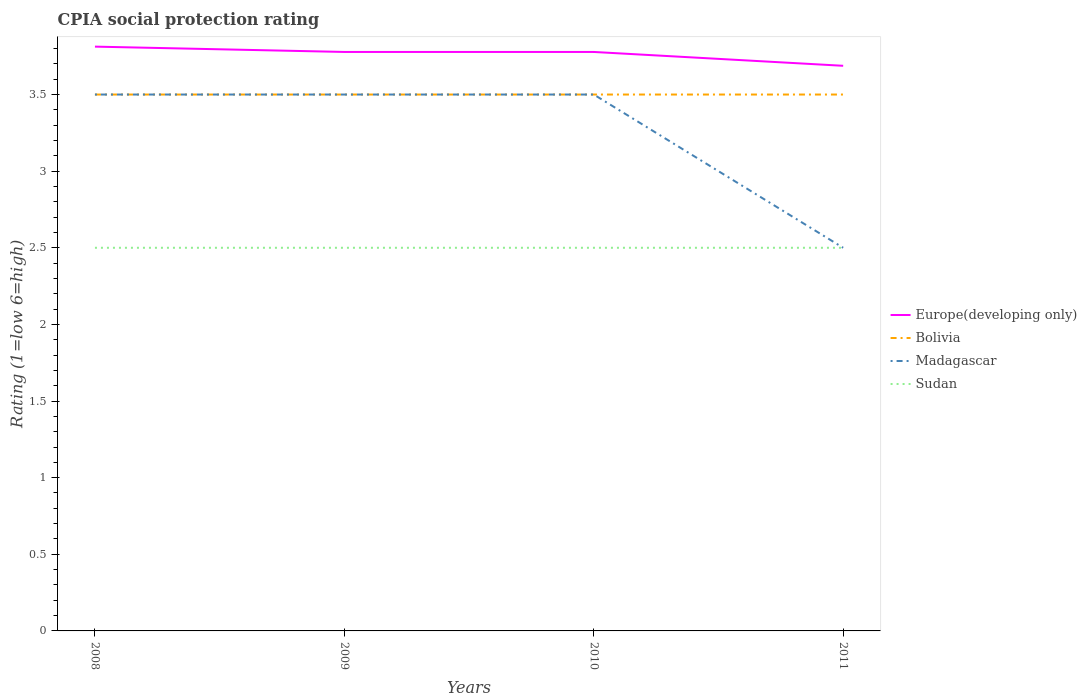In which year was the CPIA rating in Sudan maximum?
Make the answer very short. 2008. What is the difference between the highest and the second highest CPIA rating in Europe(developing only)?
Your response must be concise. 0.12. How many lines are there?
Keep it short and to the point. 4. What is the difference between two consecutive major ticks on the Y-axis?
Offer a terse response. 0.5. Are the values on the major ticks of Y-axis written in scientific E-notation?
Ensure brevity in your answer.  No. Does the graph contain any zero values?
Offer a terse response. No. How many legend labels are there?
Offer a very short reply. 4. What is the title of the graph?
Offer a very short reply. CPIA social protection rating. Does "Middle income" appear as one of the legend labels in the graph?
Make the answer very short. No. What is the label or title of the X-axis?
Ensure brevity in your answer.  Years. What is the label or title of the Y-axis?
Keep it short and to the point. Rating (1=low 6=high). What is the Rating (1=low 6=high) in Europe(developing only) in 2008?
Provide a succinct answer. 3.81. What is the Rating (1=low 6=high) of Madagascar in 2008?
Make the answer very short. 3.5. What is the Rating (1=low 6=high) of Europe(developing only) in 2009?
Your answer should be compact. 3.78. What is the Rating (1=low 6=high) of Bolivia in 2009?
Offer a very short reply. 3.5. What is the Rating (1=low 6=high) of Madagascar in 2009?
Your answer should be very brief. 3.5. What is the Rating (1=low 6=high) in Sudan in 2009?
Provide a succinct answer. 2.5. What is the Rating (1=low 6=high) in Europe(developing only) in 2010?
Make the answer very short. 3.78. What is the Rating (1=low 6=high) in Bolivia in 2010?
Your response must be concise. 3.5. What is the Rating (1=low 6=high) of Madagascar in 2010?
Your answer should be compact. 3.5. What is the Rating (1=low 6=high) of Europe(developing only) in 2011?
Make the answer very short. 3.69. What is the Rating (1=low 6=high) of Bolivia in 2011?
Ensure brevity in your answer.  3.5. Across all years, what is the maximum Rating (1=low 6=high) in Europe(developing only)?
Provide a succinct answer. 3.81. Across all years, what is the minimum Rating (1=low 6=high) of Europe(developing only)?
Your answer should be very brief. 3.69. Across all years, what is the minimum Rating (1=low 6=high) of Bolivia?
Your answer should be compact. 3.5. Across all years, what is the minimum Rating (1=low 6=high) of Madagascar?
Ensure brevity in your answer.  2.5. Across all years, what is the minimum Rating (1=low 6=high) in Sudan?
Your response must be concise. 2.5. What is the total Rating (1=low 6=high) in Europe(developing only) in the graph?
Provide a short and direct response. 15.06. What is the difference between the Rating (1=low 6=high) in Europe(developing only) in 2008 and that in 2009?
Offer a very short reply. 0.03. What is the difference between the Rating (1=low 6=high) of Madagascar in 2008 and that in 2009?
Offer a very short reply. 0. What is the difference between the Rating (1=low 6=high) of Europe(developing only) in 2008 and that in 2010?
Make the answer very short. 0.03. What is the difference between the Rating (1=low 6=high) in Bolivia in 2008 and that in 2010?
Your answer should be compact. 0. What is the difference between the Rating (1=low 6=high) in Sudan in 2008 and that in 2010?
Your answer should be very brief. 0. What is the difference between the Rating (1=low 6=high) of Madagascar in 2008 and that in 2011?
Give a very brief answer. 1. What is the difference between the Rating (1=low 6=high) of Sudan in 2008 and that in 2011?
Ensure brevity in your answer.  0. What is the difference between the Rating (1=low 6=high) of Bolivia in 2009 and that in 2010?
Your response must be concise. 0. What is the difference between the Rating (1=low 6=high) in Sudan in 2009 and that in 2010?
Your response must be concise. 0. What is the difference between the Rating (1=low 6=high) in Europe(developing only) in 2009 and that in 2011?
Make the answer very short. 0.09. What is the difference between the Rating (1=low 6=high) of Madagascar in 2009 and that in 2011?
Make the answer very short. 1. What is the difference between the Rating (1=low 6=high) in Europe(developing only) in 2010 and that in 2011?
Make the answer very short. 0.09. What is the difference between the Rating (1=low 6=high) in Bolivia in 2010 and that in 2011?
Offer a very short reply. 0. What is the difference between the Rating (1=low 6=high) in Madagascar in 2010 and that in 2011?
Give a very brief answer. 1. What is the difference between the Rating (1=low 6=high) of Europe(developing only) in 2008 and the Rating (1=low 6=high) of Bolivia in 2009?
Provide a short and direct response. 0.31. What is the difference between the Rating (1=low 6=high) in Europe(developing only) in 2008 and the Rating (1=low 6=high) in Madagascar in 2009?
Your answer should be compact. 0.31. What is the difference between the Rating (1=low 6=high) in Europe(developing only) in 2008 and the Rating (1=low 6=high) in Sudan in 2009?
Provide a short and direct response. 1.31. What is the difference between the Rating (1=low 6=high) of Bolivia in 2008 and the Rating (1=low 6=high) of Madagascar in 2009?
Provide a short and direct response. 0. What is the difference between the Rating (1=low 6=high) of Europe(developing only) in 2008 and the Rating (1=low 6=high) of Bolivia in 2010?
Your response must be concise. 0.31. What is the difference between the Rating (1=low 6=high) in Europe(developing only) in 2008 and the Rating (1=low 6=high) in Madagascar in 2010?
Ensure brevity in your answer.  0.31. What is the difference between the Rating (1=low 6=high) in Europe(developing only) in 2008 and the Rating (1=low 6=high) in Sudan in 2010?
Your answer should be compact. 1.31. What is the difference between the Rating (1=low 6=high) in Europe(developing only) in 2008 and the Rating (1=low 6=high) in Bolivia in 2011?
Make the answer very short. 0.31. What is the difference between the Rating (1=low 6=high) in Europe(developing only) in 2008 and the Rating (1=low 6=high) in Madagascar in 2011?
Offer a very short reply. 1.31. What is the difference between the Rating (1=low 6=high) of Europe(developing only) in 2008 and the Rating (1=low 6=high) of Sudan in 2011?
Offer a terse response. 1.31. What is the difference between the Rating (1=low 6=high) in Bolivia in 2008 and the Rating (1=low 6=high) in Madagascar in 2011?
Make the answer very short. 1. What is the difference between the Rating (1=low 6=high) in Madagascar in 2008 and the Rating (1=low 6=high) in Sudan in 2011?
Offer a terse response. 1. What is the difference between the Rating (1=low 6=high) in Europe(developing only) in 2009 and the Rating (1=low 6=high) in Bolivia in 2010?
Ensure brevity in your answer.  0.28. What is the difference between the Rating (1=low 6=high) in Europe(developing only) in 2009 and the Rating (1=low 6=high) in Madagascar in 2010?
Your response must be concise. 0.28. What is the difference between the Rating (1=low 6=high) in Europe(developing only) in 2009 and the Rating (1=low 6=high) in Sudan in 2010?
Keep it short and to the point. 1.28. What is the difference between the Rating (1=low 6=high) in Bolivia in 2009 and the Rating (1=low 6=high) in Madagascar in 2010?
Your response must be concise. 0. What is the difference between the Rating (1=low 6=high) of Madagascar in 2009 and the Rating (1=low 6=high) of Sudan in 2010?
Offer a terse response. 1. What is the difference between the Rating (1=low 6=high) of Europe(developing only) in 2009 and the Rating (1=low 6=high) of Bolivia in 2011?
Make the answer very short. 0.28. What is the difference between the Rating (1=low 6=high) of Europe(developing only) in 2009 and the Rating (1=low 6=high) of Madagascar in 2011?
Your response must be concise. 1.28. What is the difference between the Rating (1=low 6=high) of Europe(developing only) in 2009 and the Rating (1=low 6=high) of Sudan in 2011?
Your answer should be very brief. 1.28. What is the difference between the Rating (1=low 6=high) in Europe(developing only) in 2010 and the Rating (1=low 6=high) in Bolivia in 2011?
Ensure brevity in your answer.  0.28. What is the difference between the Rating (1=low 6=high) in Europe(developing only) in 2010 and the Rating (1=low 6=high) in Madagascar in 2011?
Keep it short and to the point. 1.28. What is the difference between the Rating (1=low 6=high) of Europe(developing only) in 2010 and the Rating (1=low 6=high) of Sudan in 2011?
Ensure brevity in your answer.  1.28. What is the difference between the Rating (1=low 6=high) in Bolivia in 2010 and the Rating (1=low 6=high) in Madagascar in 2011?
Ensure brevity in your answer.  1. What is the difference between the Rating (1=low 6=high) of Bolivia in 2010 and the Rating (1=low 6=high) of Sudan in 2011?
Your response must be concise. 1. What is the average Rating (1=low 6=high) in Europe(developing only) per year?
Your answer should be compact. 3.76. What is the average Rating (1=low 6=high) in Bolivia per year?
Your answer should be very brief. 3.5. What is the average Rating (1=low 6=high) in Madagascar per year?
Your answer should be compact. 3.25. What is the average Rating (1=low 6=high) of Sudan per year?
Give a very brief answer. 2.5. In the year 2008, what is the difference between the Rating (1=low 6=high) in Europe(developing only) and Rating (1=low 6=high) in Bolivia?
Your answer should be compact. 0.31. In the year 2008, what is the difference between the Rating (1=low 6=high) of Europe(developing only) and Rating (1=low 6=high) of Madagascar?
Provide a short and direct response. 0.31. In the year 2008, what is the difference between the Rating (1=low 6=high) in Europe(developing only) and Rating (1=low 6=high) in Sudan?
Your answer should be compact. 1.31. In the year 2008, what is the difference between the Rating (1=low 6=high) of Bolivia and Rating (1=low 6=high) of Madagascar?
Provide a short and direct response. 0. In the year 2008, what is the difference between the Rating (1=low 6=high) of Bolivia and Rating (1=low 6=high) of Sudan?
Provide a short and direct response. 1. In the year 2008, what is the difference between the Rating (1=low 6=high) of Madagascar and Rating (1=low 6=high) of Sudan?
Make the answer very short. 1. In the year 2009, what is the difference between the Rating (1=low 6=high) of Europe(developing only) and Rating (1=low 6=high) of Bolivia?
Your response must be concise. 0.28. In the year 2009, what is the difference between the Rating (1=low 6=high) of Europe(developing only) and Rating (1=low 6=high) of Madagascar?
Provide a short and direct response. 0.28. In the year 2009, what is the difference between the Rating (1=low 6=high) in Europe(developing only) and Rating (1=low 6=high) in Sudan?
Your answer should be compact. 1.28. In the year 2009, what is the difference between the Rating (1=low 6=high) of Bolivia and Rating (1=low 6=high) of Madagascar?
Offer a terse response. 0. In the year 2010, what is the difference between the Rating (1=low 6=high) of Europe(developing only) and Rating (1=low 6=high) of Bolivia?
Keep it short and to the point. 0.28. In the year 2010, what is the difference between the Rating (1=low 6=high) in Europe(developing only) and Rating (1=low 6=high) in Madagascar?
Provide a succinct answer. 0.28. In the year 2010, what is the difference between the Rating (1=low 6=high) in Europe(developing only) and Rating (1=low 6=high) in Sudan?
Your response must be concise. 1.28. In the year 2010, what is the difference between the Rating (1=low 6=high) in Bolivia and Rating (1=low 6=high) in Madagascar?
Your answer should be very brief. 0. In the year 2011, what is the difference between the Rating (1=low 6=high) of Europe(developing only) and Rating (1=low 6=high) of Bolivia?
Your response must be concise. 0.19. In the year 2011, what is the difference between the Rating (1=low 6=high) of Europe(developing only) and Rating (1=low 6=high) of Madagascar?
Keep it short and to the point. 1.19. In the year 2011, what is the difference between the Rating (1=low 6=high) of Europe(developing only) and Rating (1=low 6=high) of Sudan?
Ensure brevity in your answer.  1.19. In the year 2011, what is the difference between the Rating (1=low 6=high) in Bolivia and Rating (1=low 6=high) in Madagascar?
Your answer should be very brief. 1. What is the ratio of the Rating (1=low 6=high) in Europe(developing only) in 2008 to that in 2009?
Your answer should be compact. 1.01. What is the ratio of the Rating (1=low 6=high) of Madagascar in 2008 to that in 2009?
Your answer should be compact. 1. What is the ratio of the Rating (1=low 6=high) in Europe(developing only) in 2008 to that in 2010?
Your response must be concise. 1.01. What is the ratio of the Rating (1=low 6=high) in Bolivia in 2008 to that in 2010?
Provide a short and direct response. 1. What is the ratio of the Rating (1=low 6=high) of Sudan in 2008 to that in 2010?
Offer a very short reply. 1. What is the ratio of the Rating (1=low 6=high) in Europe(developing only) in 2008 to that in 2011?
Keep it short and to the point. 1.03. What is the ratio of the Rating (1=low 6=high) in Bolivia in 2008 to that in 2011?
Your answer should be compact. 1. What is the ratio of the Rating (1=low 6=high) in Madagascar in 2008 to that in 2011?
Offer a very short reply. 1.4. What is the ratio of the Rating (1=low 6=high) in Sudan in 2008 to that in 2011?
Your response must be concise. 1. What is the ratio of the Rating (1=low 6=high) in Europe(developing only) in 2009 to that in 2010?
Provide a succinct answer. 1. What is the ratio of the Rating (1=low 6=high) of Madagascar in 2009 to that in 2010?
Your answer should be very brief. 1. What is the ratio of the Rating (1=low 6=high) in Sudan in 2009 to that in 2010?
Give a very brief answer. 1. What is the ratio of the Rating (1=low 6=high) in Europe(developing only) in 2009 to that in 2011?
Keep it short and to the point. 1.02. What is the ratio of the Rating (1=low 6=high) of Sudan in 2009 to that in 2011?
Keep it short and to the point. 1. What is the ratio of the Rating (1=low 6=high) of Europe(developing only) in 2010 to that in 2011?
Your answer should be very brief. 1.02. What is the difference between the highest and the second highest Rating (1=low 6=high) of Europe(developing only)?
Provide a short and direct response. 0.03. What is the difference between the highest and the second highest Rating (1=low 6=high) in Sudan?
Your answer should be compact. 0. What is the difference between the highest and the lowest Rating (1=low 6=high) in Europe(developing only)?
Your answer should be very brief. 0.12. What is the difference between the highest and the lowest Rating (1=low 6=high) of Madagascar?
Your answer should be very brief. 1. 